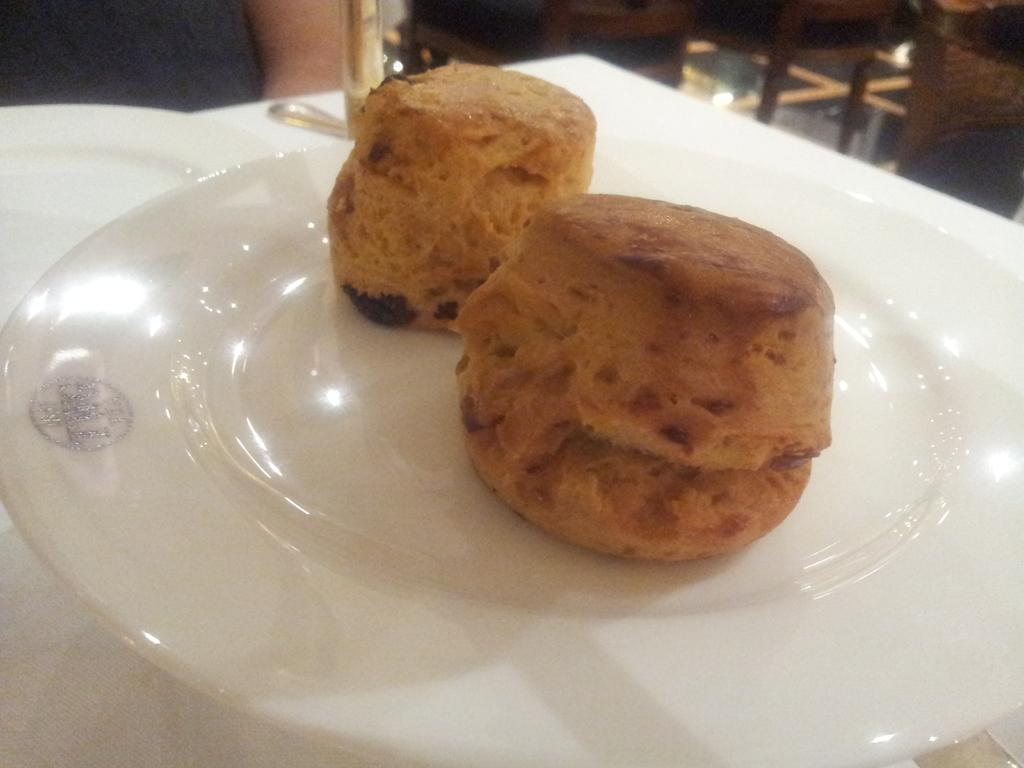Please provide a concise description of this image. In this image there is a plate on which there are two cupcakes. Beside the plate there is another plate. In the background there are chairs on the floor. On the left side top there is a person. 